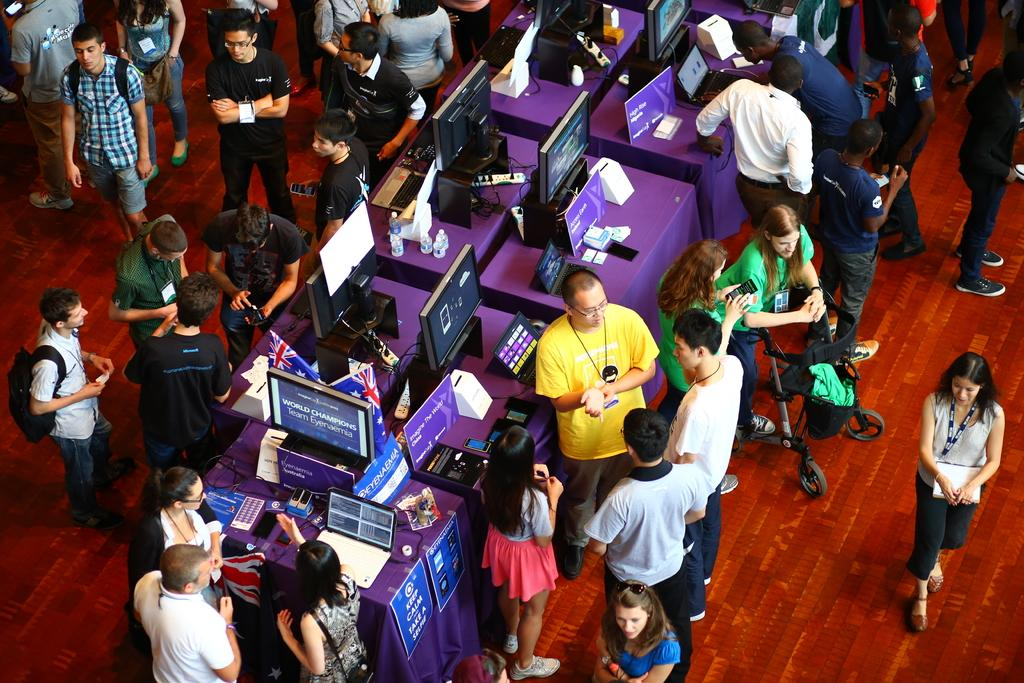What can be seen in the image? There are people standing in the image, along with monitors and a desk. Can you describe the setting of the image? The setting appears to be an office or workspace, as indicated by the presence of monitors and a desk. What might the people be doing in the image? The people in the image might be working or collaborating, given the presence of monitors and a desk. Is there a mailbox visible in the image? No, there is no mailbox present in the image. Can you see any cobwebs in the image? No, there are no cobwebs visible in the image. 